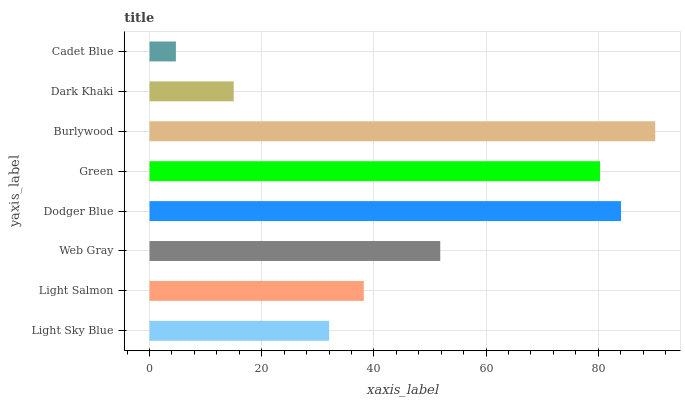Is Cadet Blue the minimum?
Answer yes or no. Yes. Is Burlywood the maximum?
Answer yes or no. Yes. Is Light Salmon the minimum?
Answer yes or no. No. Is Light Salmon the maximum?
Answer yes or no. No. Is Light Salmon greater than Light Sky Blue?
Answer yes or no. Yes. Is Light Sky Blue less than Light Salmon?
Answer yes or no. Yes. Is Light Sky Blue greater than Light Salmon?
Answer yes or no. No. Is Light Salmon less than Light Sky Blue?
Answer yes or no. No. Is Web Gray the high median?
Answer yes or no. Yes. Is Light Salmon the low median?
Answer yes or no. Yes. Is Light Sky Blue the high median?
Answer yes or no. No. Is Burlywood the low median?
Answer yes or no. No. 